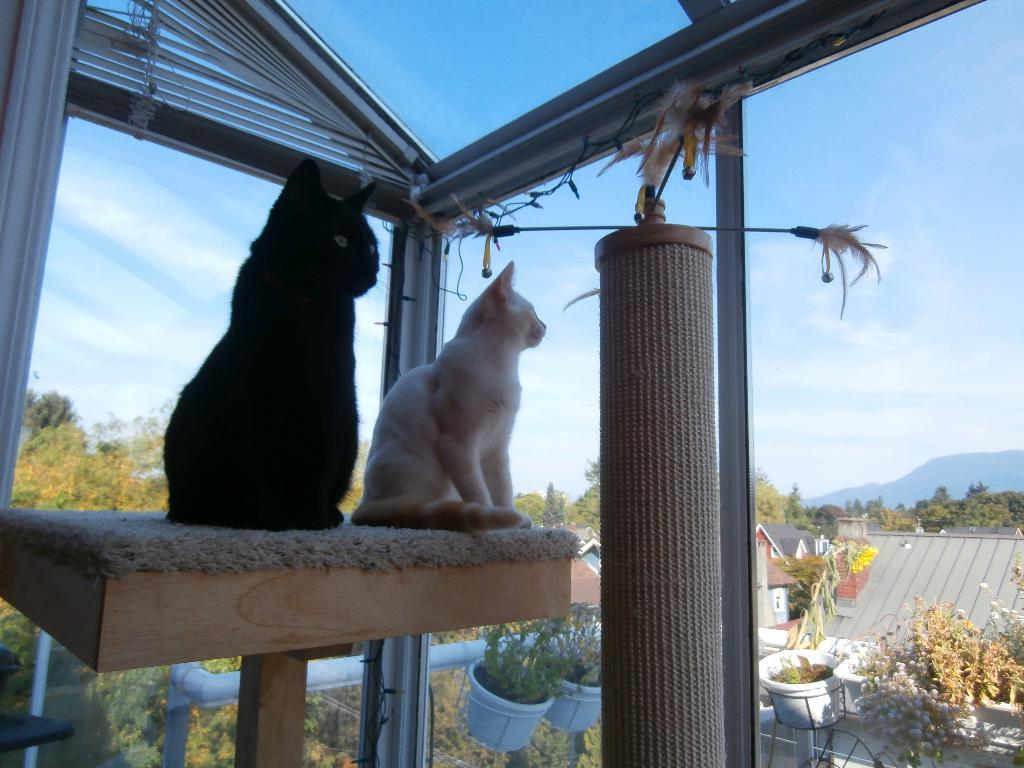How many cats are in the image? There are two cats in the image. What are the cats doing in the image? The cats are sitting on a stand and watching houses and trees. What is the main architectural feature in the image? There is a glass door in the image. What type of vacation is the cat planning in the image? There is no indication in the image that the cats are planning a vacation. What suggestion does the cat make to the other cat in the image? There is no conversation or suggestion between the cats in the image. --- Facts: 1. There is a person holding a camera in the image. 2. The person is standing on a bridge. 3. There is a river flowing under the bridge. 4. There are mountains in the background of the image. Absurd Topics: dance, book, ocean Conversation: What is the person in the image holding? The person in the image is holding a camera. Where is the person standing in the image? The person is standing on a bridge. What is flowing under the bridge in the image? There is a river flowing under the bridge. What can be seen in the background of the image? There are mountains in the background of the image. Reasoning: Let's think step by step in order to produce the conversation. We start by identifying the main subject in the image, which is the person holding a camera. Then, we describe where the person is standing, which is on a bridge. Next, we mention the river flowing under the bridge. Finally, we acknowledge the presence of mountains in the background. Absurd Question/Answer: What type of dance is the person performing on the bridge in the image? There is no indication in the image that the person is dancing or performing any dance. What book is the person reading while standing on the bridge in the image? There is no book present in the image; the person is holding a camera. --- Facts: 1. There is a person sitting on a bench in the image. 2. The person is reading a book. 3. There is a tree behind the bench. 4. There is a pond in the background of the image. Absurd Topics: parrot, bicycle, volcano Conversation: What is the person in the image doing? The person in the image is sitting on a bench and reading a book. What is located behind the bench in the image? There is a tree behind the bench. What can be seen in the background of the image? There is a pond in the background of the image. Reasoning: Let's think step by step in order to produce the conversation. We start by identifying the main subject in the image, which is the person sitting on a bench. Then, we describe what the person is doing, which is reading a book. Next, we mention the tree located behind the bench 